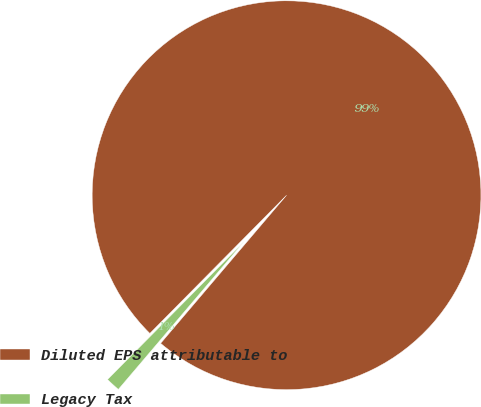<chart> <loc_0><loc_0><loc_500><loc_500><pie_chart><fcel>Diluted EPS attributable to<fcel>Legacy Tax<nl><fcel>98.8%<fcel>1.2%<nl></chart> 